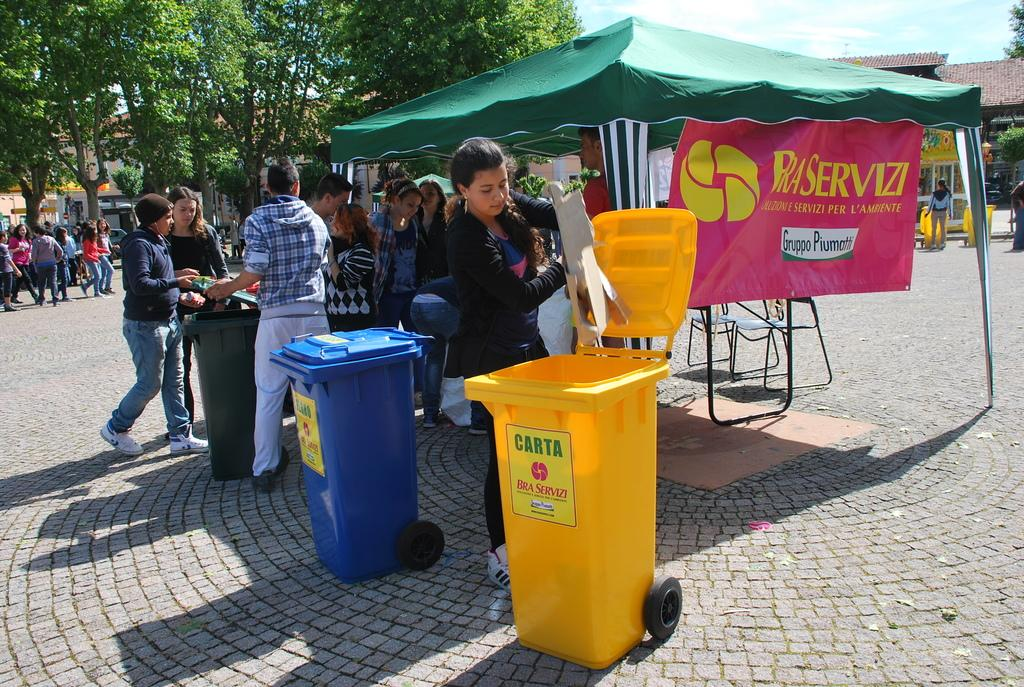<image>
Create a compact narrative representing the image presented. A yellow trash bin at an outdoor food fair that says carta 